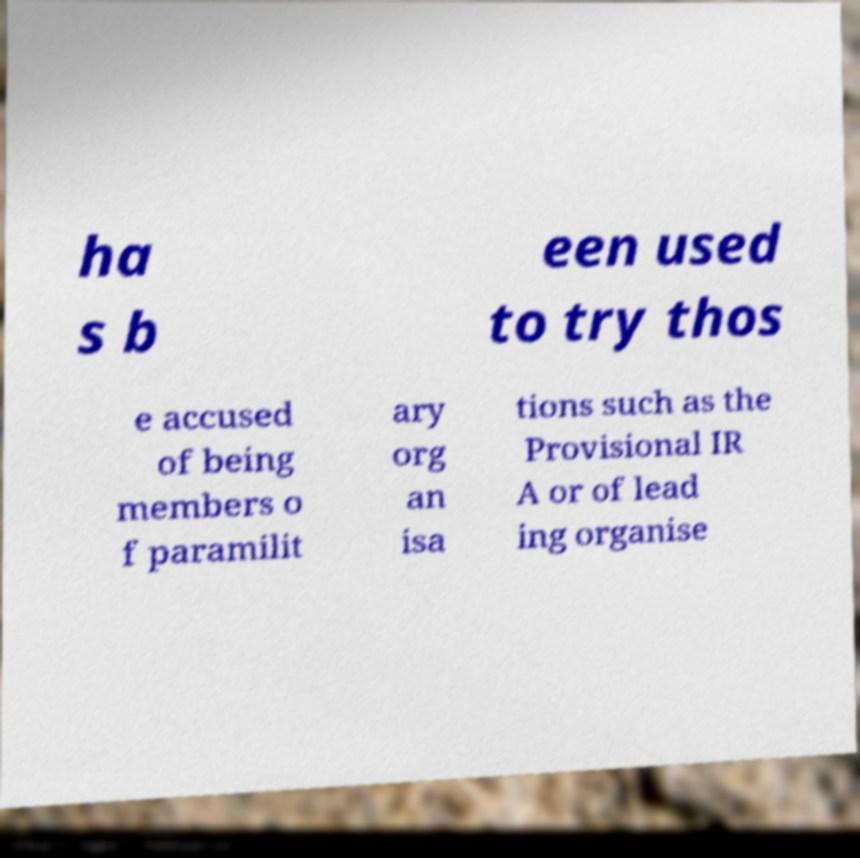Could you assist in decoding the text presented in this image and type it out clearly? ha s b een used to try thos e accused of being members o f paramilit ary org an isa tions such as the Provisional IR A or of lead ing organise 